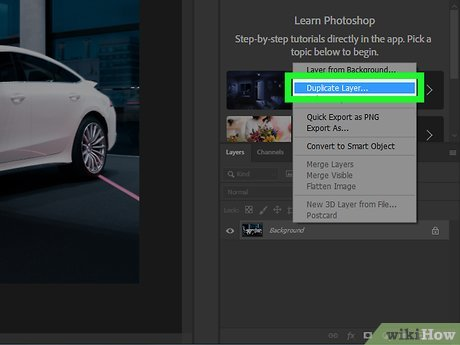Can you describe a scenario where duplicating layers might be especially useful? One scenario where duplicating layers is especially useful is in compositing images, where multiple elements from different sources are combined to create a single image. By duplicating layers, you can adjust each element's properties such as opacity, blending modes, or apply filters independently, allowing for a highly controlled and versatile creative process. What are some risks or pitfalls in using too many duplicated layers? Using too many duplicated layers can lead to a few issues. Primarily, it can significantly increase the file size, potentially slowing down the software and making it less responsive. Additionally, managing a large number of layers can be complex, increasing the risk of errors or confusion in keeping track of changes and the intended effects on each layer. 